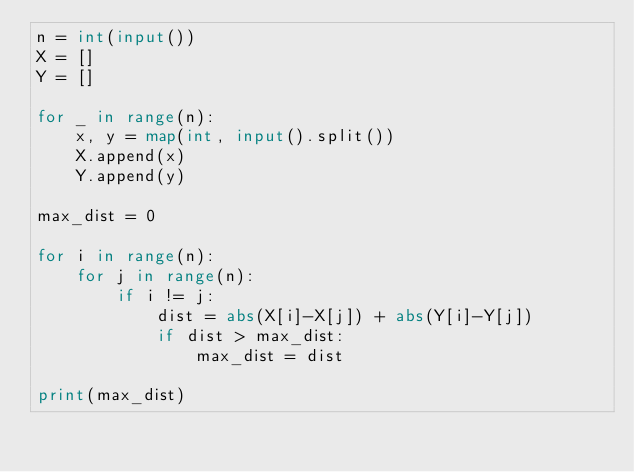<code> <loc_0><loc_0><loc_500><loc_500><_Python_>n = int(input())
X = []
Y = []

for _ in range(n):
    x, y = map(int, input().split())
    X.append(x)
    Y.append(y)

max_dist = 0

for i in range(n):
    for j in range(n):
        if i != j:
            dist = abs(X[i]-X[j]) + abs(Y[i]-Y[j])
            if dist > max_dist:
                max_dist = dist

print(max_dist)</code> 